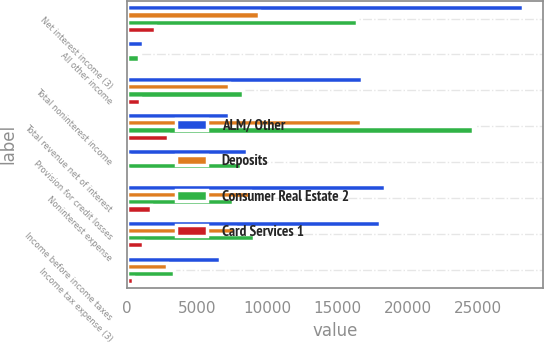Convert chart. <chart><loc_0><loc_0><loc_500><loc_500><stacked_bar_chart><ecel><fcel>Net interest income (3)<fcel>All other income<fcel>Total noninterest income<fcel>Total revenue net of interest<fcel>Provision for credit losses<fcel>Noninterest expense<fcel>Income before income taxes<fcel>Income tax expense (3)<nl><fcel>ALM/ Other<fcel>28197<fcel>1136<fcel>16729<fcel>7246<fcel>8534<fcel>18375<fcel>18017<fcel>6639<nl><fcel>Deposits<fcel>9405<fcel>1<fcel>7246<fcel>16651<fcel>165<fcel>8783<fcel>7703<fcel>2840<nl><fcel>Consumer Real Estate 2<fcel>16357<fcel>819<fcel>8279<fcel>24636<fcel>8089<fcel>7519<fcel>9028<fcel>3328<nl><fcel>Card Services 1<fcel>1994<fcel>27<fcel>915<fcel>2909<fcel>63<fcel>1718<fcel>1128<fcel>416<nl></chart> 